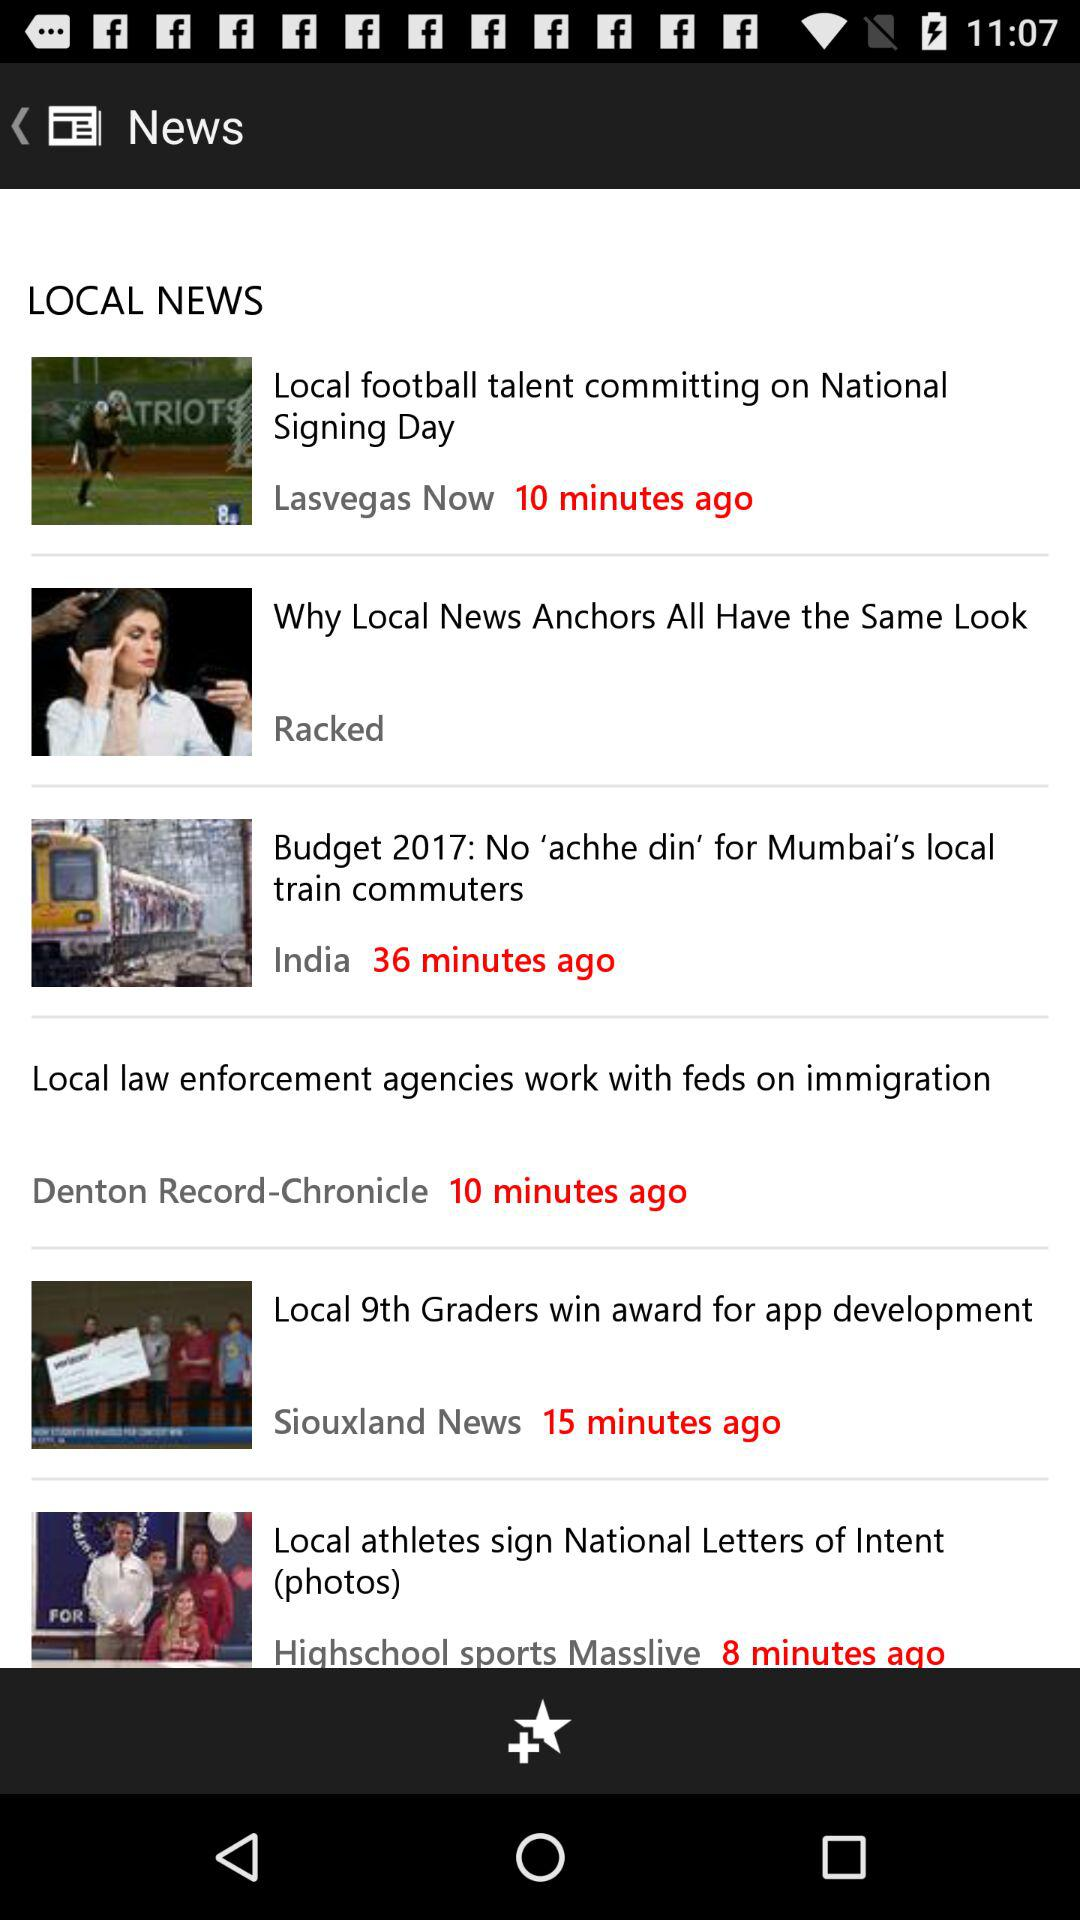What was the time when the local 9th graders wins news update?
When the provided information is insufficient, respond with <no answer>. <no answer> 